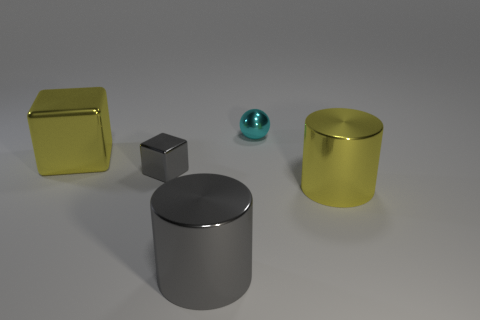Subtract all gray blocks. How many blocks are left? 1 Add 2 large blue matte cylinders. How many objects exist? 7 Subtract all cylinders. How many objects are left? 3 Subtract all blue blocks. Subtract all brown balls. How many blocks are left? 2 Subtract all purple spheres. How many gray cylinders are left? 1 Subtract all gray things. Subtract all gray metal things. How many objects are left? 1 Add 2 small things. How many small things are left? 4 Add 5 small metal things. How many small metal things exist? 7 Subtract 0 brown spheres. How many objects are left? 5 